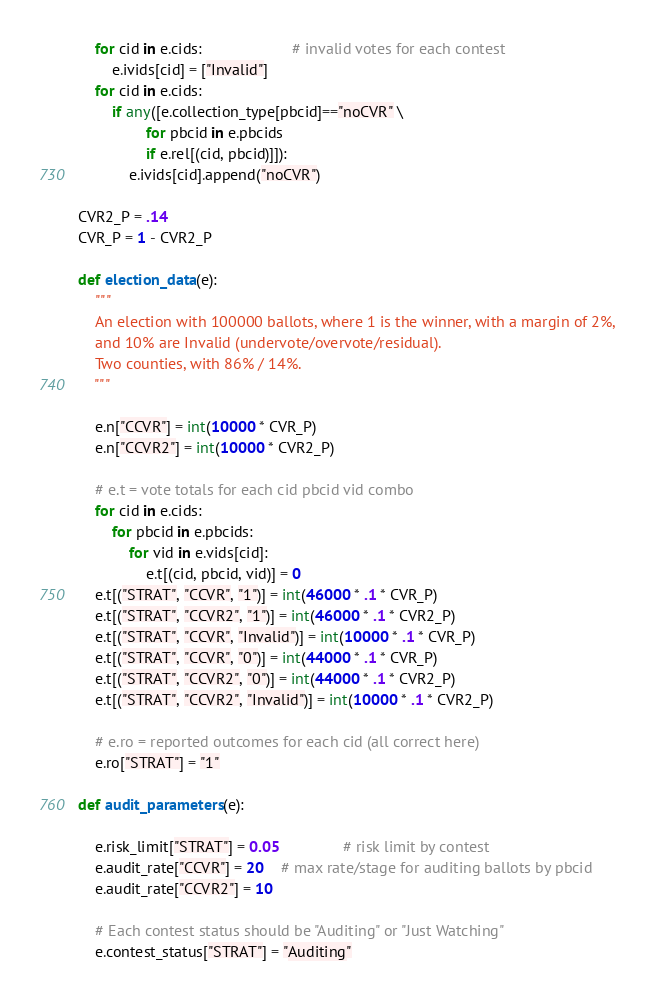Convert code to text. <code><loc_0><loc_0><loc_500><loc_500><_Python_>    for cid in e.cids:                     # invalid votes for each contest
        e.ivids[cid] = ["Invalid"]
    for cid in e.cids:
        if any([e.collection_type[pbcid]=="noCVR" \
                for pbcid in e.pbcids
                if e.rel[(cid, pbcid)]]):
            e.ivids[cid].append("noCVR")

CVR2_P = .14
CVR_P = 1 - CVR2_P

def election_data(e):
    """
    An election with 100000 ballots, where 1 is the winner, with a margin of 2%,
    and 10% are Invalid (undervote/overvote/residual).
    Two counties, with 86% / 14%.
    """

    e.n["CCVR"] = int(10000 * CVR_P)
    e.n["CCVR2"] = int(10000 * CVR2_P)

    # e.t = vote totals for each cid pbcid vid combo
    for cid in e.cids:
        for pbcid in e.pbcids:
            for vid in e.vids[cid]:
                e.t[(cid, pbcid, vid)] = 0
    e.t[("STRAT", "CCVR", "1")] = int(46000 * .1 * CVR_P)
    e.t[("STRAT", "CCVR2", "1")] = int(46000 * .1 * CVR2_P)
    e.t[("STRAT", "CCVR", "Invalid")] = int(10000 * .1 * CVR_P)
    e.t[("STRAT", "CCVR", "0")] = int(44000 * .1 * CVR_P)
    e.t[("STRAT", "CCVR2", "0")] = int(44000 * .1 * CVR2_P)
    e.t[("STRAT", "CCVR2", "Invalid")] = int(10000 * .1 * CVR2_P)
    
    # e.ro = reported outcomes for each cid (all correct here)
    e.ro["STRAT"] = "1"                         

def audit_parameters(e):

    e.risk_limit["STRAT"] = 0.05               # risk limit by contest
    e.audit_rate["CCVR"] = 20    # max rate/stage for auditing ballots by pbcid
    e.audit_rate["CCVR2"] = 10 

    # Each contest status should be "Auditing" or "Just Watching"
    e.contest_status["STRAT"] = "Auditing"
</code> 